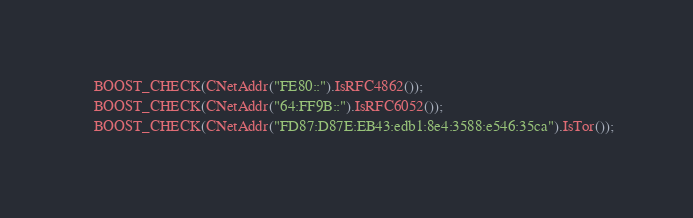Convert code to text. <code><loc_0><loc_0><loc_500><loc_500><_C++_>    BOOST_CHECK(CNetAddr("FE80::").IsRFC4862());
    BOOST_CHECK(CNetAddr("64:FF9B::").IsRFC6052());
    BOOST_CHECK(CNetAddr("FD87:D87E:EB43:edb1:8e4:3588:e546:35ca").IsTor());</code> 